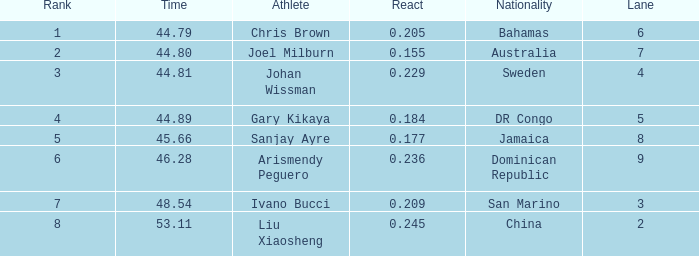What is the total average for Rank entries where the Lane listed is smaller than 4 and the Nationality listed is San Marino? 7.0. 